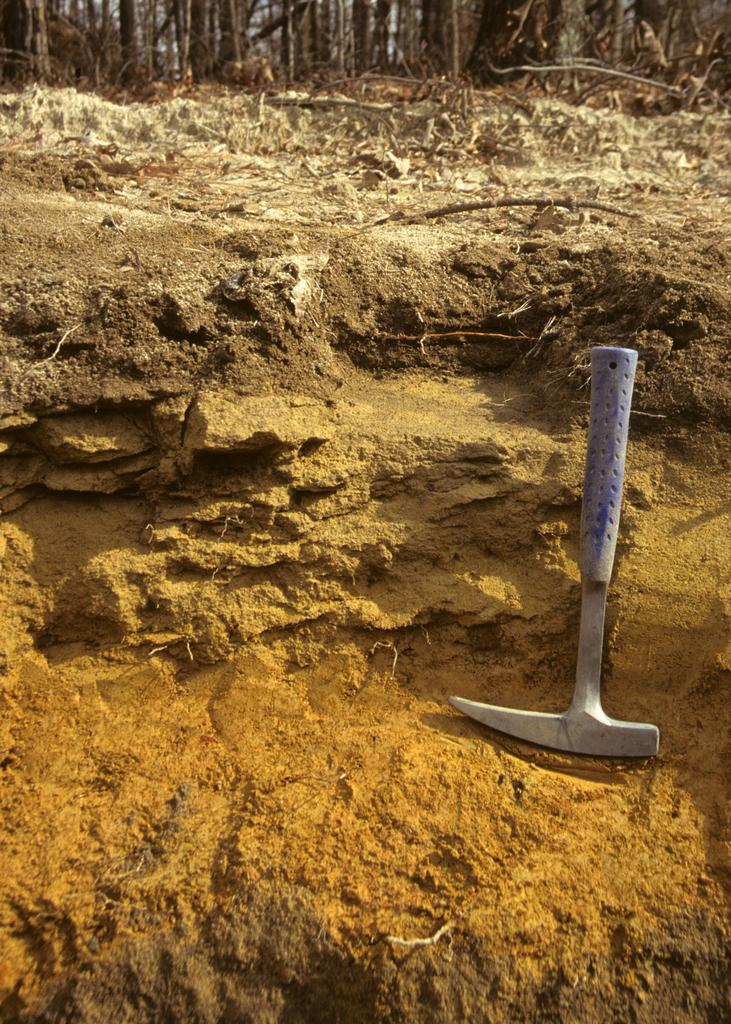What object can be seen on the ground on the right side of the image? There is a tool on the ground on the right side of the image. What else can be found on the ground in the image? Leaves and sticks are present on the ground in the background of the image. Can you tell me what type of humor the owl is displaying in the image? There is no owl present in the image, so it is not possible to determine the type of humor being displayed. 